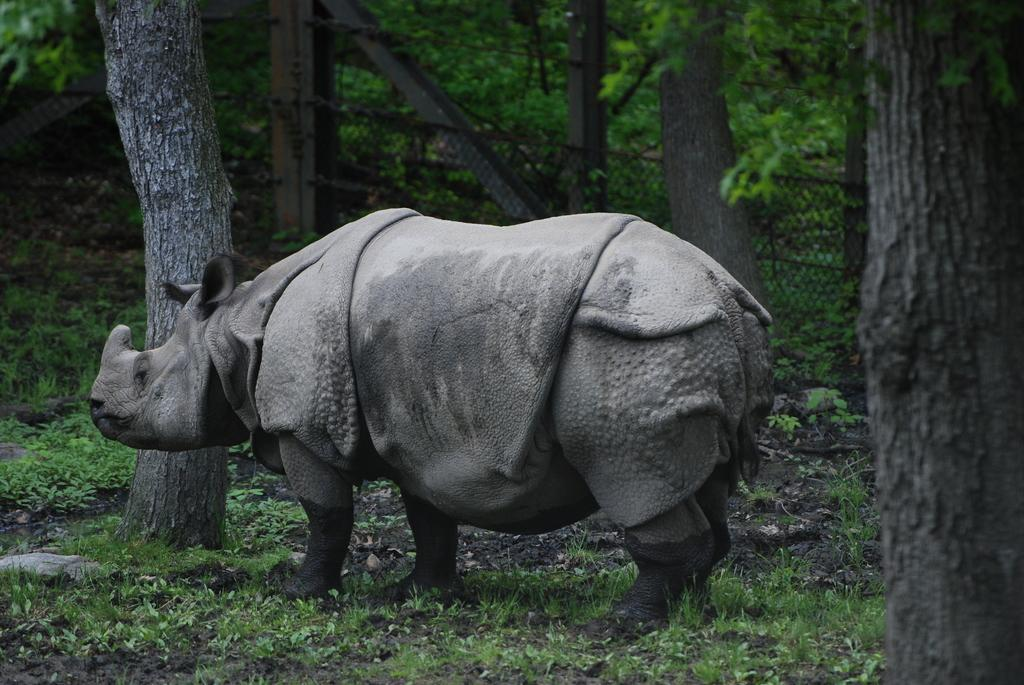What animal is present in the image? There is a rhinoceros in the image. What can be seen in the background of the image? There are trees in the background of the image. What type of vegetation is visible in the image? There are plants in the image. How many pizzas can be seen hanging from the trees in the image? There are no pizzas present in the image; it features a rhinoceros and trees. Is there an airplane visible in the image? No, there is no airplane present in the image. Can you see a swing in the image? No, there is no swing present in the image. 